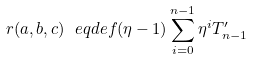<formula> <loc_0><loc_0><loc_500><loc_500>r ( a , b , c ) \ e q d e f ( \eta - 1 ) \sum _ { i = 0 } ^ { n - 1 } \eta ^ { i } T _ { n - 1 } ^ { \prime }</formula> 